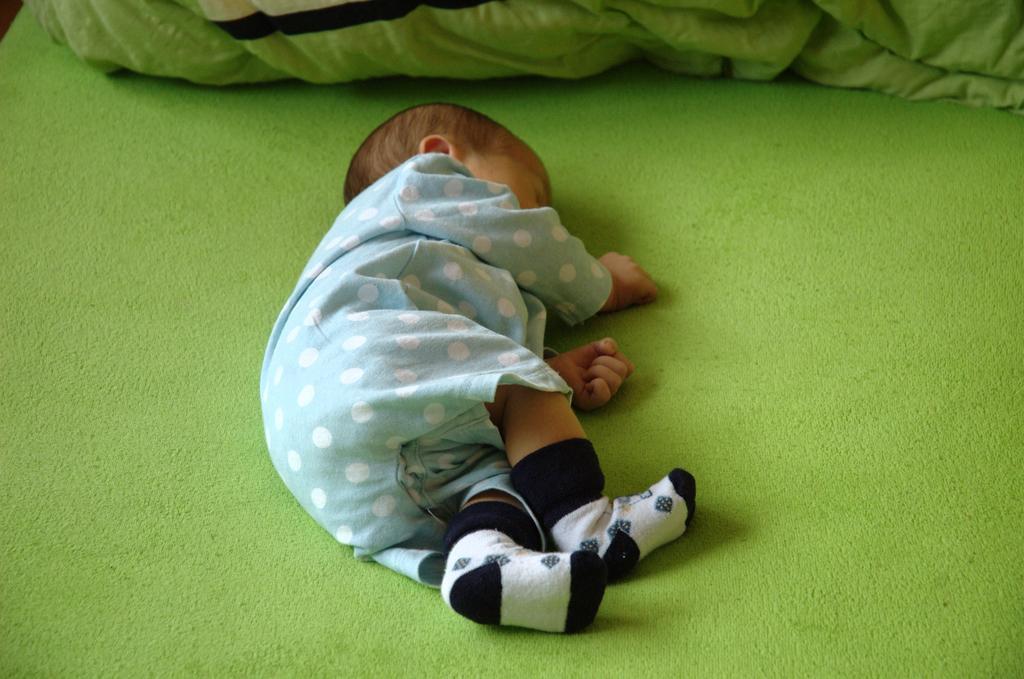In one or two sentences, can you explain what this image depicts? In the picture I can see a child is sleeping on a green color surface. The child is wearing blue color dress and socks. 